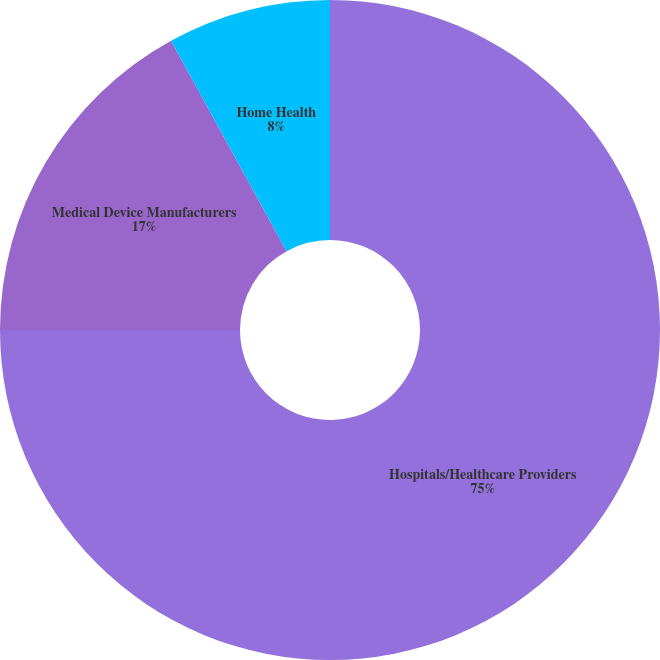Convert chart. <chart><loc_0><loc_0><loc_500><loc_500><pie_chart><fcel>Hospitals/Healthcare Providers<fcel>Medical Device Manufacturers<fcel>Home Health<nl><fcel>75.0%<fcel>17.0%<fcel>8.0%<nl></chart> 